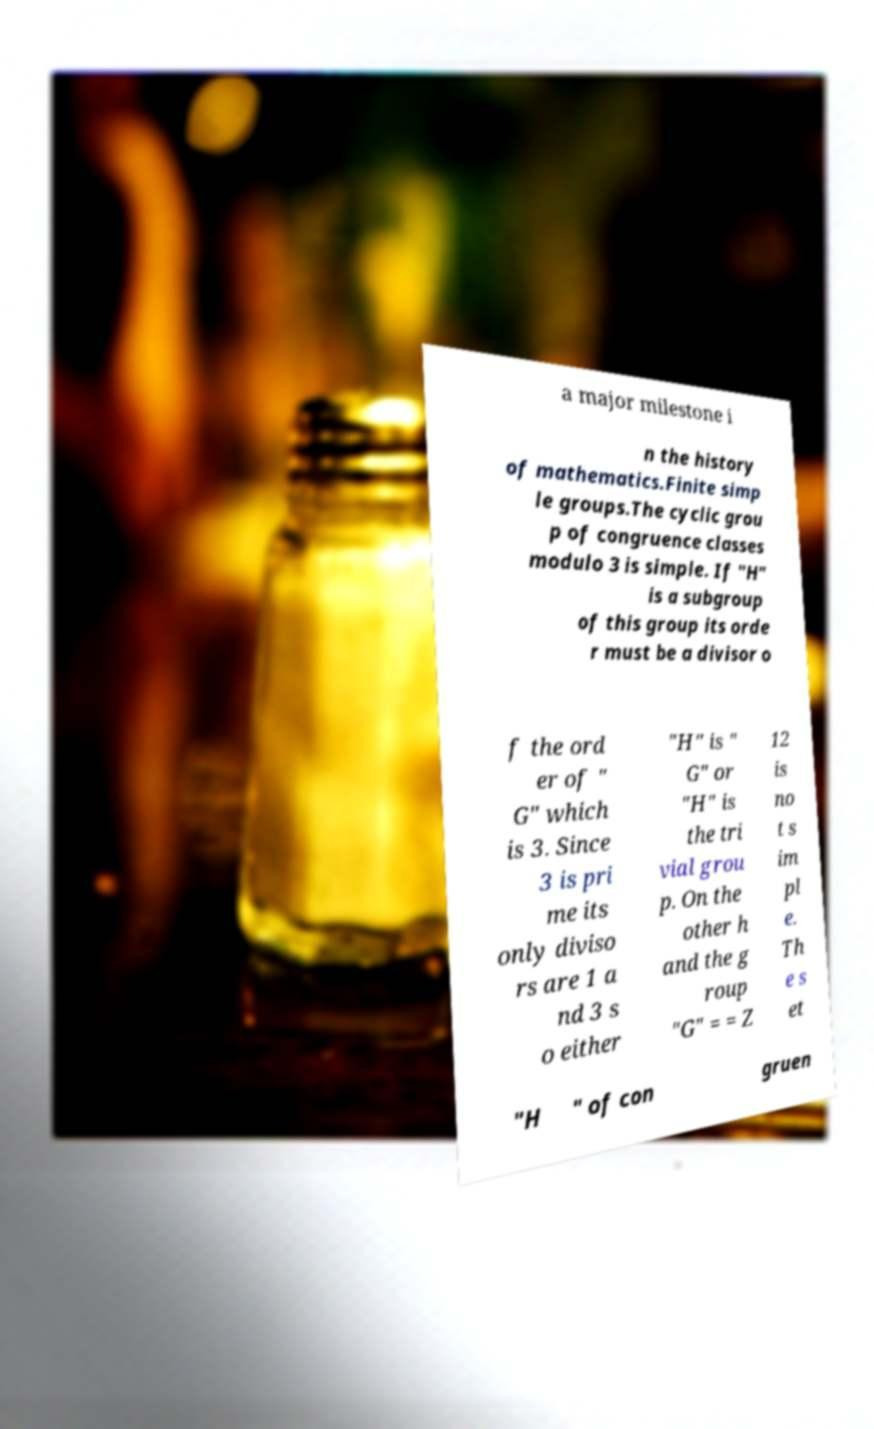For documentation purposes, I need the text within this image transcribed. Could you provide that? a major milestone i n the history of mathematics.Finite simp le groups.The cyclic grou p of congruence classes modulo 3 is simple. If "H" is a subgroup of this group its orde r must be a divisor o f the ord er of " G" which is 3. Since 3 is pri me its only diviso rs are 1 a nd 3 s o either "H" is " G" or "H" is the tri vial grou p. On the other h and the g roup "G" = = Z 12 is no t s im pl e. Th e s et "H " of con gruen 